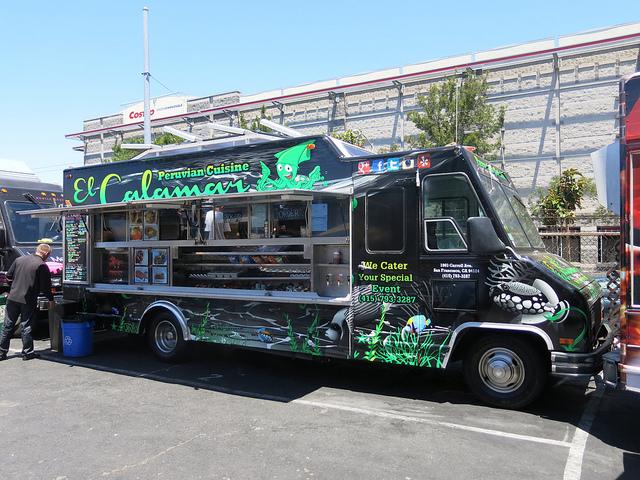Is this a Mexican truck?
Concise answer only. Yes. What is this truck doing?
Answer briefly. Selling food. Does this truck sell food?
Concise answer only. Yes. 